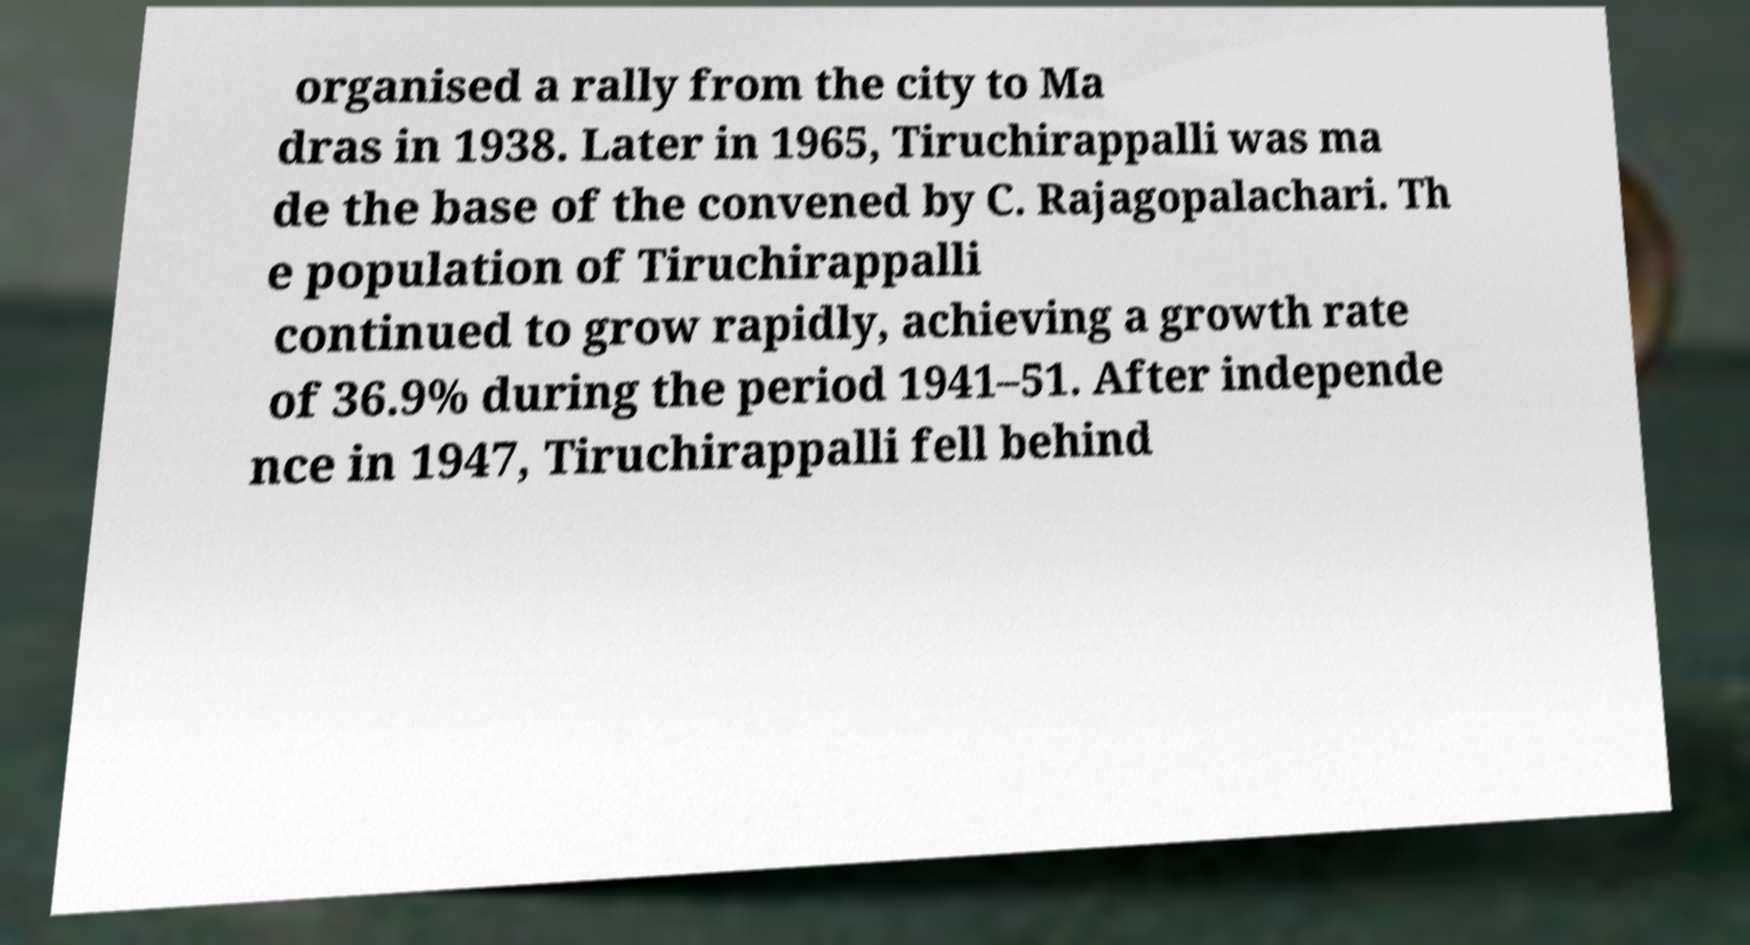I need the written content from this picture converted into text. Can you do that? organised a rally from the city to Ma dras in 1938. Later in 1965, Tiruchirappalli was ma de the base of the convened by C. Rajagopalachari. Th e population of Tiruchirappalli continued to grow rapidly, achieving a growth rate of 36.9% during the period 1941–51. After independe nce in 1947, Tiruchirappalli fell behind 